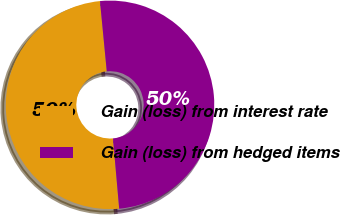Convert chart to OTSL. <chart><loc_0><loc_0><loc_500><loc_500><pie_chart><fcel>Gain (loss) from interest rate<fcel>Gain (loss) from hedged items<nl><fcel>49.87%<fcel>50.13%<nl></chart> 